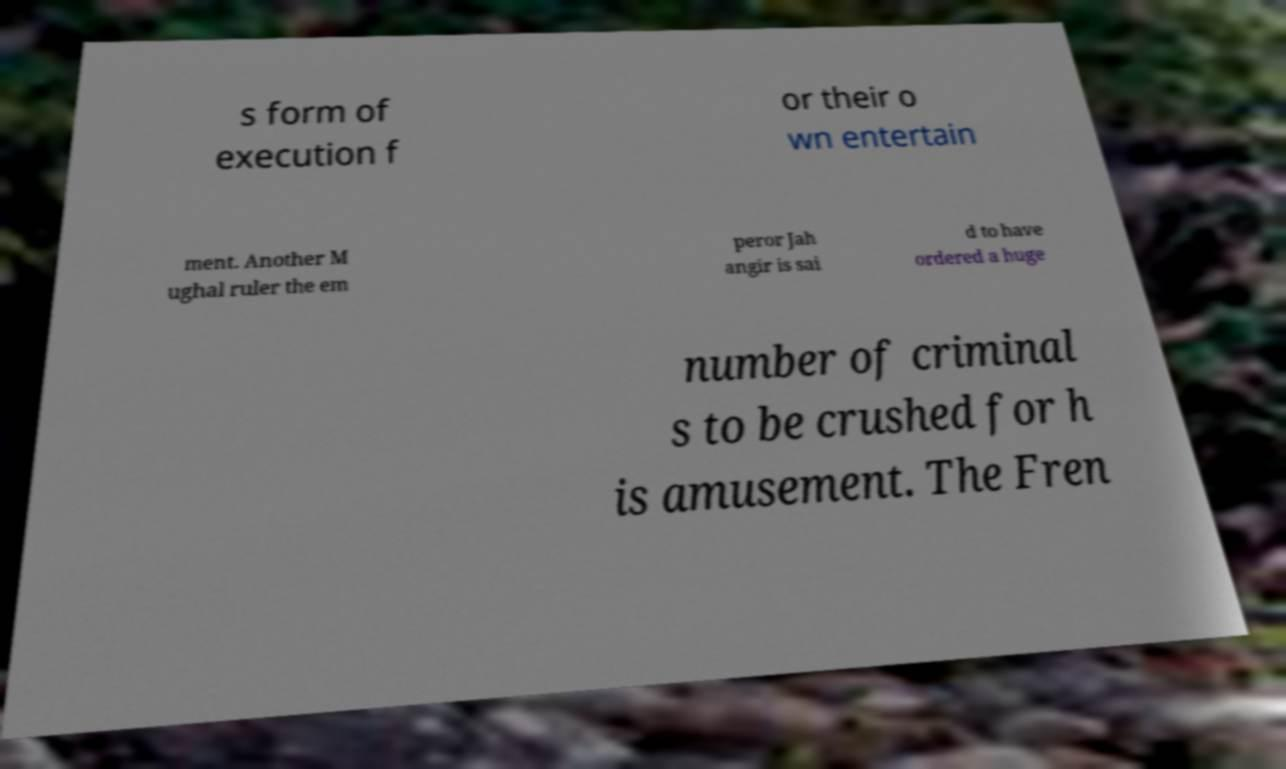I need the written content from this picture converted into text. Can you do that? s form of execution f or their o wn entertain ment. Another M ughal ruler the em peror Jah angir is sai d to have ordered a huge number of criminal s to be crushed for h is amusement. The Fren 